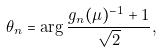Convert formula to latex. <formula><loc_0><loc_0><loc_500><loc_500>\theta _ { n } = \arg \frac { g _ { n } ( \mu ) ^ { - 1 } + 1 } { \sqrt { 2 } } ,</formula> 